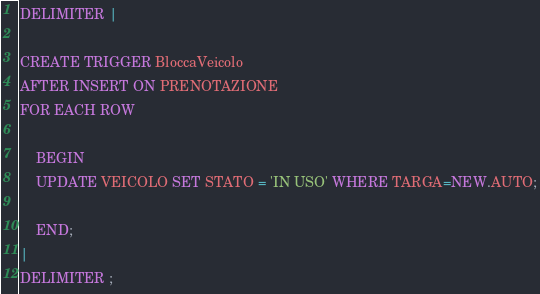Convert code to text. <code><loc_0><loc_0><loc_500><loc_500><_SQL_>DELIMITER |

CREATE TRIGGER BloccaVeicolo
AFTER INSERT ON PRENOTAZIONE
FOR EACH ROW
	
    BEGIN
    UPDATE VEICOLO SET STATO = 'IN USO' WHERE TARGA=NEW.AUTO;
	
    END;
|
DELIMITER ;</code> 